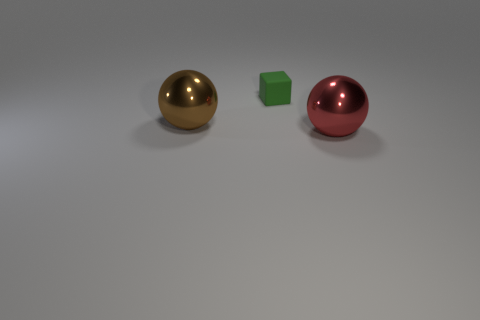There is a brown metal thing that is the same size as the red sphere; what shape is it? sphere 